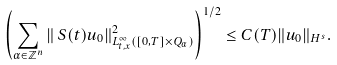<formula> <loc_0><loc_0><loc_500><loc_500>\left ( \sum _ { \alpha \in \mathbb { Z } ^ { n } } \| \, S ( t ) u _ { 0 } \| ^ { 2 } _ { L ^ { \infty } _ { t , x } ( [ 0 , T ] \times Q _ { \alpha } ) } \right ) ^ { 1 / 2 } \leq C ( T ) \| u _ { 0 } \| _ { H ^ { s } } .</formula> 